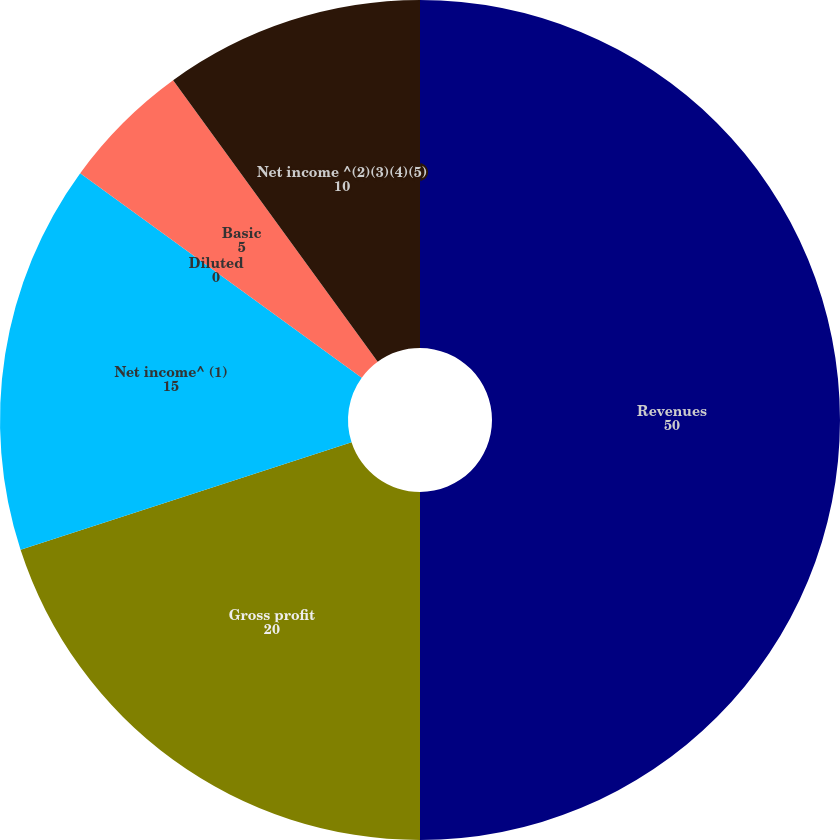Convert chart. <chart><loc_0><loc_0><loc_500><loc_500><pie_chart><fcel>Revenues<fcel>Gross profit<fcel>Net income^ (1)<fcel>Diluted<fcel>Basic<fcel>Net income ^(2)(3)(4)(5)<nl><fcel>50.0%<fcel>20.0%<fcel>15.0%<fcel>0.0%<fcel>5.0%<fcel>10.0%<nl></chart> 